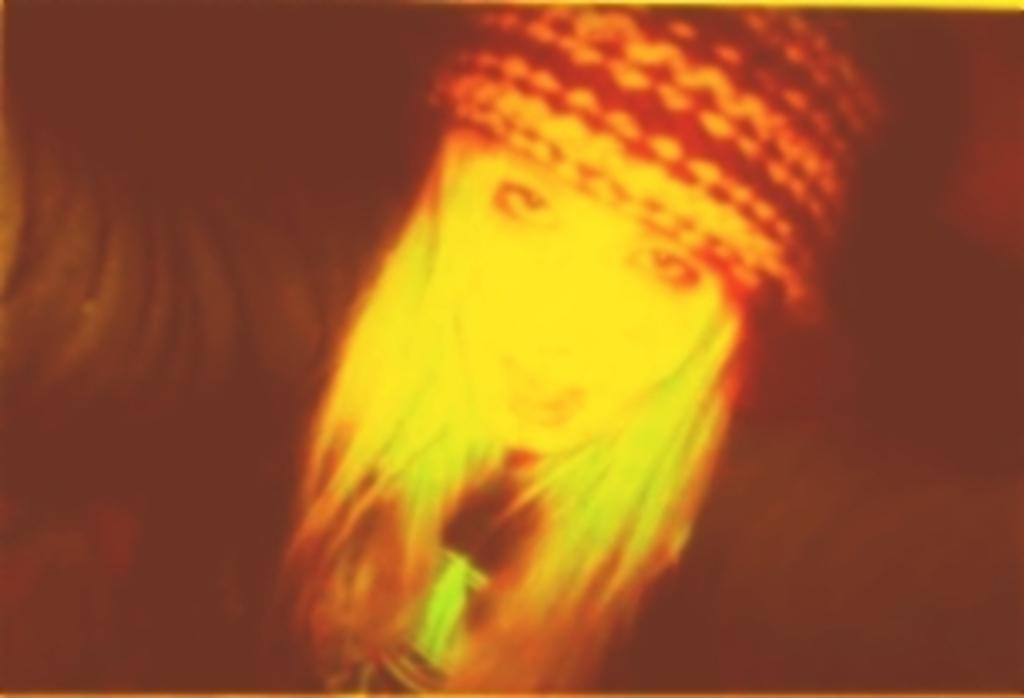What is the main subject of the image? There is a person in the image. What is the person wearing on their head? The person is wearing a cap. What can be observed about the background of the image? The background of the image is dark in color. How many toes can be seen on the person's feet in the image? There is no visible indication of the person's feet or toes in the image. 